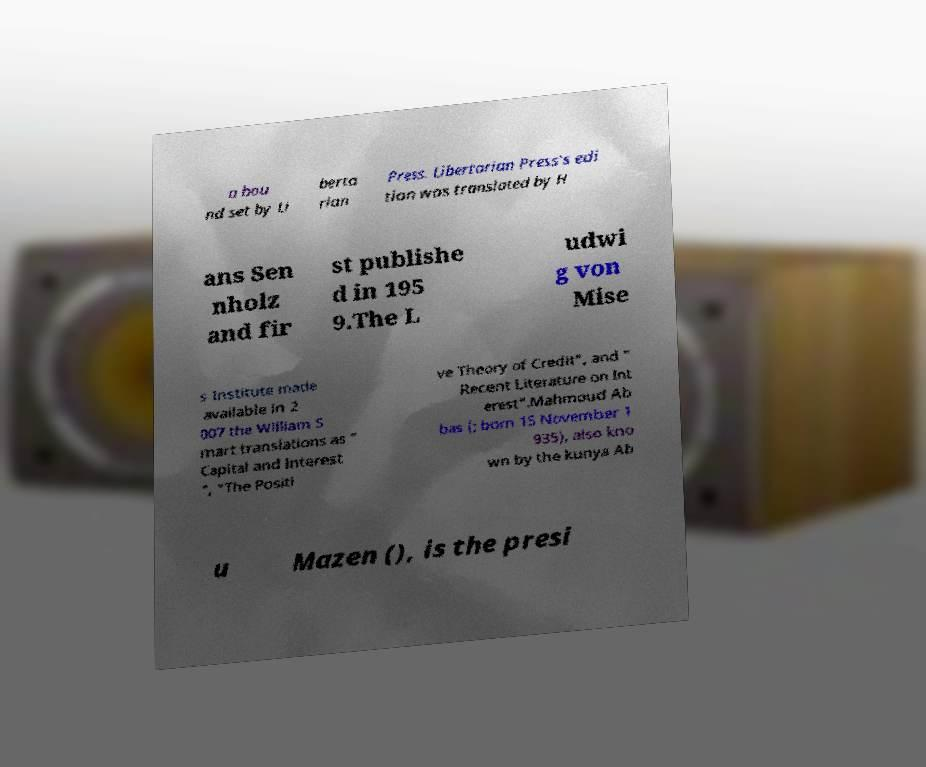Could you extract and type out the text from this image? a bou nd set by Li berta rian Press. Libertarian Press's edi tion was translated by H ans Sen nholz and fir st publishe d in 195 9.The L udwi g von Mise s Institute made available in 2 007 the William S mart translations as " Capital and Interest ", "The Positi ve Theory of Credit", and " Recent Literature on Int erest".Mahmoud Ab bas (; born 15 November 1 935), also kno wn by the kunya Ab u Mazen (), is the presi 